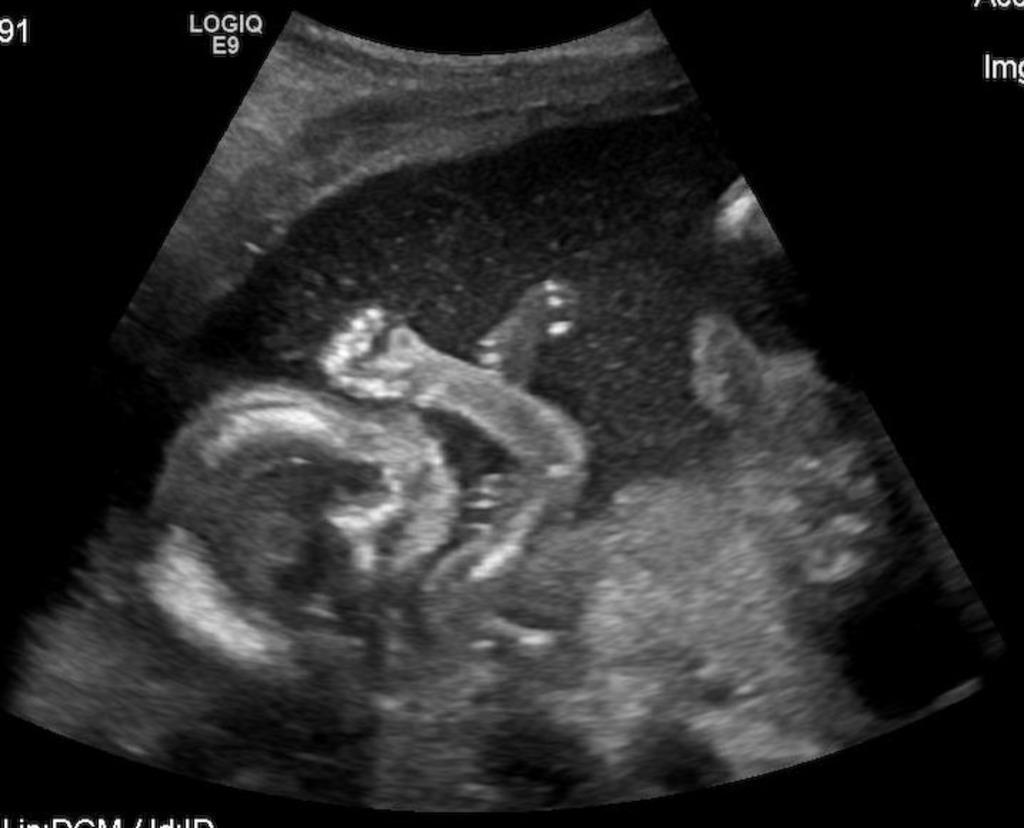What is the main subject in the image? There is a scanning report in the image. What else can be seen in the image besides the scanning report? There is a display and a kid visible in the image. What type of wound can be seen on the leather jacket the mother is wearing in the image? There is no mother or leather jacket present in the image. 